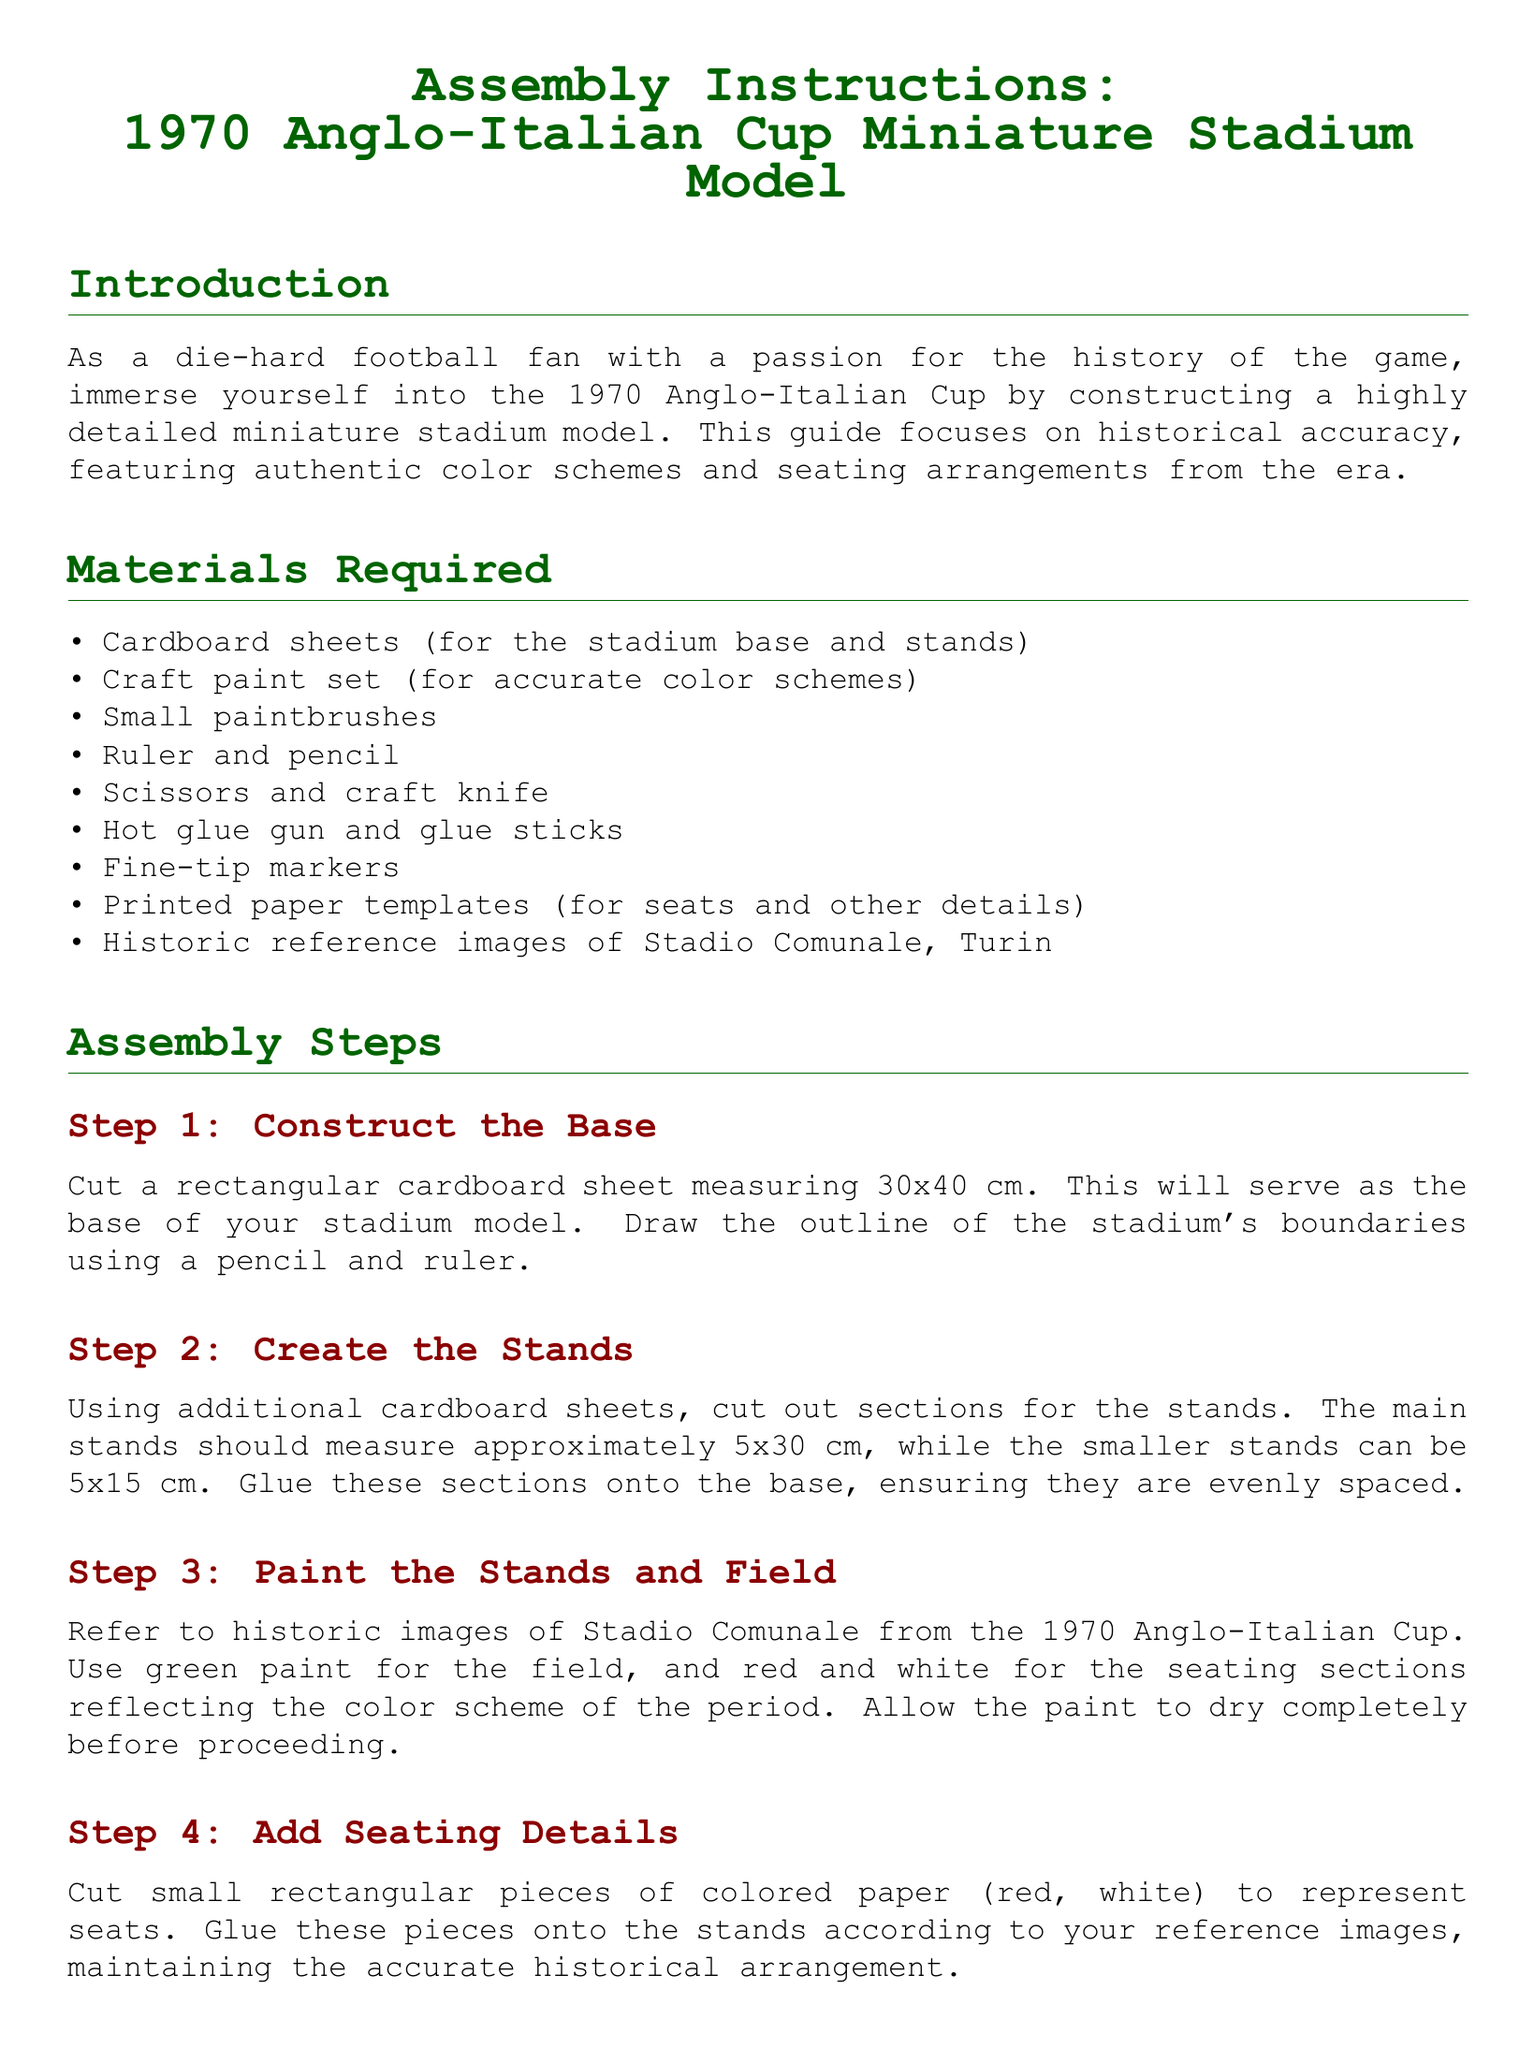What is the title of the document? The title of the document is stated prominently at the beginning, indicating its purpose and focus on the 1970 Anglo-Italian Cup.
Answer: Assembly Instructions: 1970 Anglo-Italian Cup Miniature Stadium Model What are the dimensions of the base for the stadium model? The document specifies that the rectangular cardboard sheet for the base should measure 30x40 cm.
Answer: 30x40 cm What colors are used for the seating sections? The instructions indicate the colors used for the seating sections as red and white based on historical references.
Answer: Red and white How many steps are involved in the assembly process? The assembly steps are listed clearly in the document, and counting the ones listed gives the total number of steps.
Answer: Six What tools are needed for cutting materials? The document lists the tools required for construction, and specific tools are mentioned for cutting materials in the assembly.
Answer: Scissors and craft knife What type of paint is recommended for the field? The relevant step in the instructions outlines the colors needed for the field, indicating what type of paint should be used.
Answer: Green paint What additional materials help in constructing the scoreboard and floodlights? The assembly instructions outline specific items required to create additional stadium features, including printed templates.
Answer: Cardboard and printed templates What is the main theme emphasized in the assembly instructions? The introduction specifies the guiding principle for the project, highlighting the focus on accurate representation.
Answer: Historical accuracy Which historic stadium is referenced for color schemes and seating arrangements? The document mentions a particular stadium as a reference for constructing the model, which contributes to its authenticity.
Answer: Stadio Comunale, Turin 